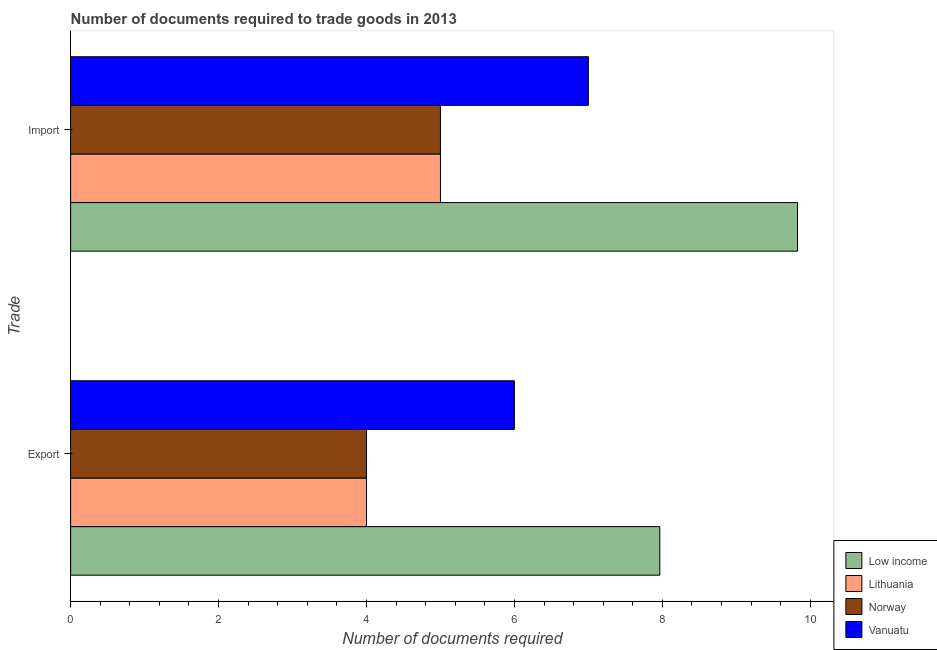Are the number of bars per tick equal to the number of legend labels?
Offer a very short reply. Yes. Are the number of bars on each tick of the Y-axis equal?
Provide a short and direct response. Yes. How many bars are there on the 1st tick from the top?
Make the answer very short. 4. What is the label of the 2nd group of bars from the top?
Provide a short and direct response. Export. What is the number of documents required to export goods in Lithuania?
Keep it short and to the point. 4. Across all countries, what is the maximum number of documents required to import goods?
Your answer should be compact. 9.83. In which country was the number of documents required to export goods minimum?
Ensure brevity in your answer.  Lithuania. What is the total number of documents required to import goods in the graph?
Your answer should be compact. 26.83. What is the difference between the number of documents required to import goods in Norway and the number of documents required to export goods in Low income?
Ensure brevity in your answer.  -2.97. What is the average number of documents required to import goods per country?
Ensure brevity in your answer.  6.71. What is the difference between the number of documents required to export goods and number of documents required to import goods in Lithuania?
Keep it short and to the point. -1. In how many countries, is the number of documents required to import goods greater than 2 ?
Provide a succinct answer. 4. Is the number of documents required to export goods in Vanuatu less than that in Norway?
Make the answer very short. No. In how many countries, is the number of documents required to import goods greater than the average number of documents required to import goods taken over all countries?
Provide a short and direct response. 2. What does the 2nd bar from the bottom in Import represents?
Your response must be concise. Lithuania. Are all the bars in the graph horizontal?
Make the answer very short. Yes. What is the title of the graph?
Your response must be concise. Number of documents required to trade goods in 2013. Does "Estonia" appear as one of the legend labels in the graph?
Your response must be concise. No. What is the label or title of the X-axis?
Keep it short and to the point. Number of documents required. What is the label or title of the Y-axis?
Give a very brief answer. Trade. What is the Number of documents required in Low income in Export?
Offer a very short reply. 7.97. What is the Number of documents required of Lithuania in Export?
Provide a succinct answer. 4. What is the Number of documents required of Norway in Export?
Your answer should be compact. 4. What is the Number of documents required in Low income in Import?
Your answer should be very brief. 9.83. What is the Number of documents required of Lithuania in Import?
Keep it short and to the point. 5. Across all Trade, what is the maximum Number of documents required in Low income?
Offer a very short reply. 9.83. Across all Trade, what is the maximum Number of documents required of Lithuania?
Offer a terse response. 5. Across all Trade, what is the maximum Number of documents required of Vanuatu?
Provide a short and direct response. 7. Across all Trade, what is the minimum Number of documents required of Low income?
Offer a terse response. 7.97. What is the total Number of documents required of Low income in the graph?
Keep it short and to the point. 17.79. What is the total Number of documents required of Lithuania in the graph?
Make the answer very short. 9. What is the total Number of documents required of Norway in the graph?
Your answer should be very brief. 9. What is the total Number of documents required in Vanuatu in the graph?
Make the answer very short. 13. What is the difference between the Number of documents required of Low income in Export and that in Import?
Offer a very short reply. -1.86. What is the difference between the Number of documents required in Low income in Export and the Number of documents required in Lithuania in Import?
Make the answer very short. 2.97. What is the difference between the Number of documents required of Low income in Export and the Number of documents required of Norway in Import?
Provide a succinct answer. 2.97. What is the difference between the Number of documents required in Low income in Export and the Number of documents required in Vanuatu in Import?
Your answer should be very brief. 0.97. What is the average Number of documents required in Low income per Trade?
Give a very brief answer. 8.9. What is the average Number of documents required in Lithuania per Trade?
Ensure brevity in your answer.  4.5. What is the average Number of documents required in Norway per Trade?
Provide a short and direct response. 4.5. What is the average Number of documents required of Vanuatu per Trade?
Your response must be concise. 6.5. What is the difference between the Number of documents required in Low income and Number of documents required in Lithuania in Export?
Your answer should be compact. 3.97. What is the difference between the Number of documents required of Low income and Number of documents required of Norway in Export?
Offer a terse response. 3.97. What is the difference between the Number of documents required in Low income and Number of documents required in Vanuatu in Export?
Your response must be concise. 1.97. What is the difference between the Number of documents required in Lithuania and Number of documents required in Vanuatu in Export?
Give a very brief answer. -2. What is the difference between the Number of documents required of Low income and Number of documents required of Lithuania in Import?
Ensure brevity in your answer.  4.83. What is the difference between the Number of documents required in Low income and Number of documents required in Norway in Import?
Ensure brevity in your answer.  4.83. What is the difference between the Number of documents required in Low income and Number of documents required in Vanuatu in Import?
Your response must be concise. 2.83. What is the difference between the Number of documents required of Lithuania and Number of documents required of Norway in Import?
Offer a very short reply. 0. What is the difference between the Number of documents required of Norway and Number of documents required of Vanuatu in Import?
Give a very brief answer. -2. What is the ratio of the Number of documents required in Low income in Export to that in Import?
Offer a terse response. 0.81. What is the ratio of the Number of documents required in Lithuania in Export to that in Import?
Your answer should be compact. 0.8. What is the ratio of the Number of documents required in Norway in Export to that in Import?
Provide a short and direct response. 0.8. What is the difference between the highest and the second highest Number of documents required in Low income?
Provide a succinct answer. 1.86. What is the difference between the highest and the second highest Number of documents required in Norway?
Keep it short and to the point. 1. What is the difference between the highest and the lowest Number of documents required of Low income?
Make the answer very short. 1.86. What is the difference between the highest and the lowest Number of documents required of Norway?
Your answer should be compact. 1. What is the difference between the highest and the lowest Number of documents required in Vanuatu?
Provide a short and direct response. 1. 